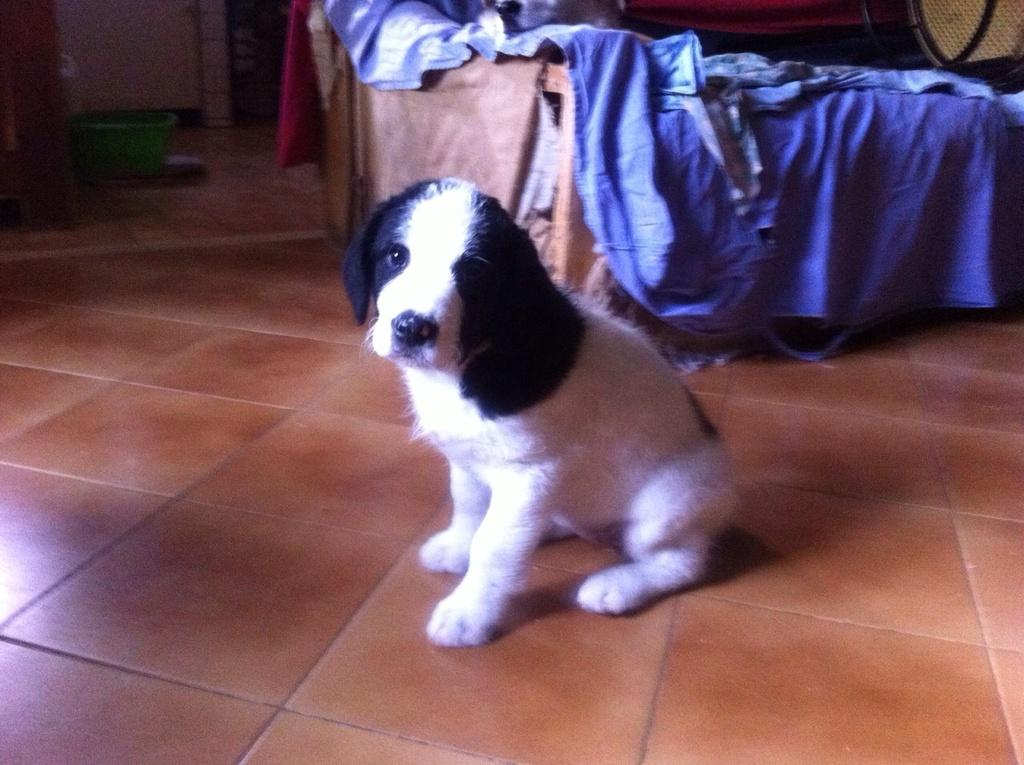What type of flooring is visible in the image? The floor has tiles. What animal can be seen in the image? There is a dog in the image. What object is located in the distance in the image? There is a container in the distance. How does the secretary use the card in the image? There is no secretary or card present in the image. 